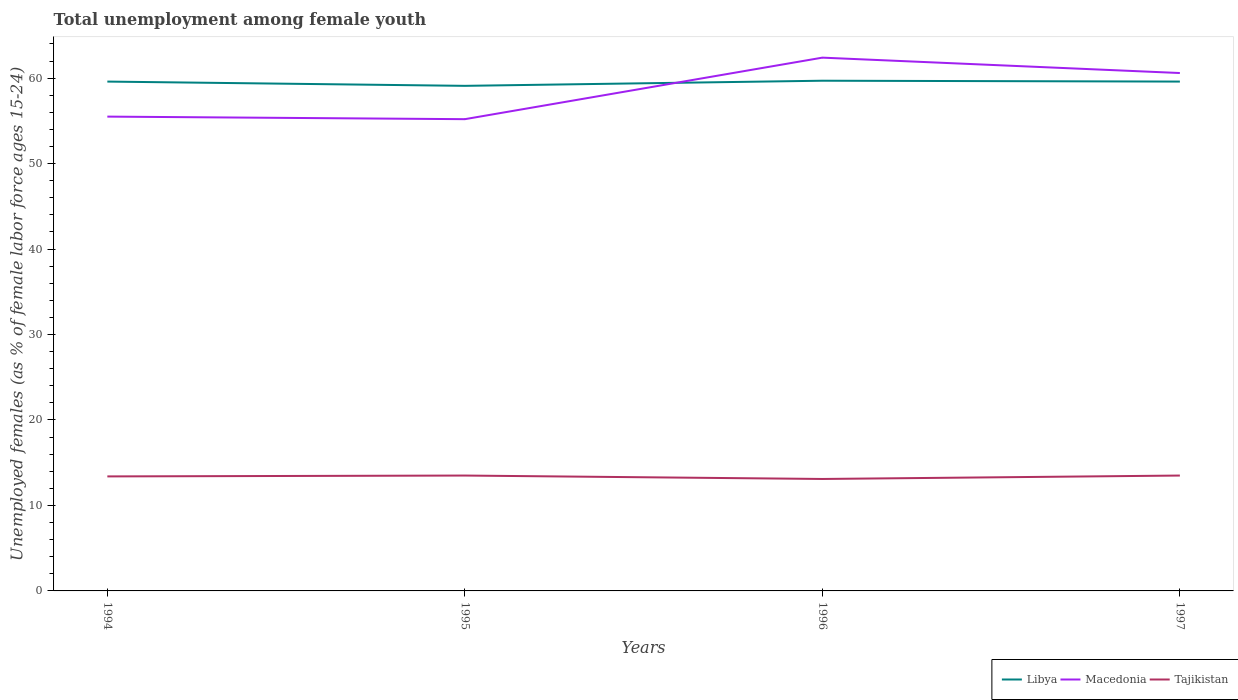Across all years, what is the maximum percentage of unemployed females in in Libya?
Your answer should be very brief. 59.1. What is the total percentage of unemployed females in in Macedonia in the graph?
Your answer should be compact. 1.8. What is the difference between the highest and the second highest percentage of unemployed females in in Macedonia?
Provide a short and direct response. 7.2. How many years are there in the graph?
Give a very brief answer. 4. What is the difference between two consecutive major ticks on the Y-axis?
Your answer should be compact. 10. Are the values on the major ticks of Y-axis written in scientific E-notation?
Make the answer very short. No. Does the graph contain any zero values?
Provide a short and direct response. No. Does the graph contain grids?
Give a very brief answer. No. Where does the legend appear in the graph?
Offer a very short reply. Bottom right. How many legend labels are there?
Give a very brief answer. 3. How are the legend labels stacked?
Offer a terse response. Horizontal. What is the title of the graph?
Give a very brief answer. Total unemployment among female youth. What is the label or title of the Y-axis?
Provide a short and direct response. Unemployed females (as % of female labor force ages 15-24). What is the Unemployed females (as % of female labor force ages 15-24) of Libya in 1994?
Make the answer very short. 59.6. What is the Unemployed females (as % of female labor force ages 15-24) of Macedonia in 1994?
Offer a very short reply. 55.5. What is the Unemployed females (as % of female labor force ages 15-24) of Tajikistan in 1994?
Give a very brief answer. 13.4. What is the Unemployed females (as % of female labor force ages 15-24) in Libya in 1995?
Offer a very short reply. 59.1. What is the Unemployed females (as % of female labor force ages 15-24) of Macedonia in 1995?
Provide a short and direct response. 55.2. What is the Unemployed females (as % of female labor force ages 15-24) in Libya in 1996?
Offer a very short reply. 59.7. What is the Unemployed females (as % of female labor force ages 15-24) of Macedonia in 1996?
Provide a succinct answer. 62.4. What is the Unemployed females (as % of female labor force ages 15-24) in Tajikistan in 1996?
Offer a very short reply. 13.1. What is the Unemployed females (as % of female labor force ages 15-24) of Libya in 1997?
Ensure brevity in your answer.  59.6. What is the Unemployed females (as % of female labor force ages 15-24) in Macedonia in 1997?
Make the answer very short. 60.6. What is the Unemployed females (as % of female labor force ages 15-24) in Tajikistan in 1997?
Ensure brevity in your answer.  13.5. Across all years, what is the maximum Unemployed females (as % of female labor force ages 15-24) in Libya?
Your answer should be very brief. 59.7. Across all years, what is the maximum Unemployed females (as % of female labor force ages 15-24) of Macedonia?
Your response must be concise. 62.4. Across all years, what is the minimum Unemployed females (as % of female labor force ages 15-24) in Libya?
Ensure brevity in your answer.  59.1. Across all years, what is the minimum Unemployed females (as % of female labor force ages 15-24) of Macedonia?
Give a very brief answer. 55.2. Across all years, what is the minimum Unemployed females (as % of female labor force ages 15-24) in Tajikistan?
Provide a short and direct response. 13.1. What is the total Unemployed females (as % of female labor force ages 15-24) of Libya in the graph?
Offer a terse response. 238. What is the total Unemployed females (as % of female labor force ages 15-24) of Macedonia in the graph?
Provide a succinct answer. 233.7. What is the total Unemployed females (as % of female labor force ages 15-24) of Tajikistan in the graph?
Give a very brief answer. 53.5. What is the difference between the Unemployed females (as % of female labor force ages 15-24) of Macedonia in 1994 and that in 1995?
Offer a terse response. 0.3. What is the difference between the Unemployed females (as % of female labor force ages 15-24) in Libya in 1994 and that in 1996?
Provide a succinct answer. -0.1. What is the difference between the Unemployed females (as % of female labor force ages 15-24) of Libya in 1994 and that in 1997?
Your answer should be compact. 0. What is the difference between the Unemployed females (as % of female labor force ages 15-24) of Libya in 1995 and that in 1997?
Give a very brief answer. -0.5. What is the difference between the Unemployed females (as % of female labor force ages 15-24) of Libya in 1996 and that in 1997?
Your answer should be very brief. 0.1. What is the difference between the Unemployed females (as % of female labor force ages 15-24) in Tajikistan in 1996 and that in 1997?
Keep it short and to the point. -0.4. What is the difference between the Unemployed females (as % of female labor force ages 15-24) of Libya in 1994 and the Unemployed females (as % of female labor force ages 15-24) of Tajikistan in 1995?
Offer a terse response. 46.1. What is the difference between the Unemployed females (as % of female labor force ages 15-24) in Macedonia in 1994 and the Unemployed females (as % of female labor force ages 15-24) in Tajikistan in 1995?
Offer a very short reply. 42. What is the difference between the Unemployed females (as % of female labor force ages 15-24) of Libya in 1994 and the Unemployed females (as % of female labor force ages 15-24) of Tajikistan in 1996?
Make the answer very short. 46.5. What is the difference between the Unemployed females (as % of female labor force ages 15-24) of Macedonia in 1994 and the Unemployed females (as % of female labor force ages 15-24) of Tajikistan in 1996?
Offer a terse response. 42.4. What is the difference between the Unemployed females (as % of female labor force ages 15-24) in Libya in 1994 and the Unemployed females (as % of female labor force ages 15-24) in Macedonia in 1997?
Your answer should be compact. -1. What is the difference between the Unemployed females (as % of female labor force ages 15-24) of Libya in 1994 and the Unemployed females (as % of female labor force ages 15-24) of Tajikistan in 1997?
Keep it short and to the point. 46.1. What is the difference between the Unemployed females (as % of female labor force ages 15-24) in Libya in 1995 and the Unemployed females (as % of female labor force ages 15-24) in Tajikistan in 1996?
Your answer should be compact. 46. What is the difference between the Unemployed females (as % of female labor force ages 15-24) in Macedonia in 1995 and the Unemployed females (as % of female labor force ages 15-24) in Tajikistan in 1996?
Ensure brevity in your answer.  42.1. What is the difference between the Unemployed females (as % of female labor force ages 15-24) of Libya in 1995 and the Unemployed females (as % of female labor force ages 15-24) of Macedonia in 1997?
Your response must be concise. -1.5. What is the difference between the Unemployed females (as % of female labor force ages 15-24) in Libya in 1995 and the Unemployed females (as % of female labor force ages 15-24) in Tajikistan in 1997?
Keep it short and to the point. 45.6. What is the difference between the Unemployed females (as % of female labor force ages 15-24) of Macedonia in 1995 and the Unemployed females (as % of female labor force ages 15-24) of Tajikistan in 1997?
Your answer should be very brief. 41.7. What is the difference between the Unemployed females (as % of female labor force ages 15-24) of Libya in 1996 and the Unemployed females (as % of female labor force ages 15-24) of Tajikistan in 1997?
Your answer should be compact. 46.2. What is the difference between the Unemployed females (as % of female labor force ages 15-24) in Macedonia in 1996 and the Unemployed females (as % of female labor force ages 15-24) in Tajikistan in 1997?
Provide a succinct answer. 48.9. What is the average Unemployed females (as % of female labor force ages 15-24) of Libya per year?
Your answer should be compact. 59.5. What is the average Unemployed females (as % of female labor force ages 15-24) in Macedonia per year?
Keep it short and to the point. 58.42. What is the average Unemployed females (as % of female labor force ages 15-24) of Tajikistan per year?
Offer a terse response. 13.38. In the year 1994, what is the difference between the Unemployed females (as % of female labor force ages 15-24) of Libya and Unemployed females (as % of female labor force ages 15-24) of Tajikistan?
Ensure brevity in your answer.  46.2. In the year 1994, what is the difference between the Unemployed females (as % of female labor force ages 15-24) of Macedonia and Unemployed females (as % of female labor force ages 15-24) of Tajikistan?
Your answer should be very brief. 42.1. In the year 1995, what is the difference between the Unemployed females (as % of female labor force ages 15-24) in Libya and Unemployed females (as % of female labor force ages 15-24) in Tajikistan?
Your answer should be very brief. 45.6. In the year 1995, what is the difference between the Unemployed females (as % of female labor force ages 15-24) of Macedonia and Unemployed females (as % of female labor force ages 15-24) of Tajikistan?
Your response must be concise. 41.7. In the year 1996, what is the difference between the Unemployed females (as % of female labor force ages 15-24) in Libya and Unemployed females (as % of female labor force ages 15-24) in Macedonia?
Your answer should be compact. -2.7. In the year 1996, what is the difference between the Unemployed females (as % of female labor force ages 15-24) in Libya and Unemployed females (as % of female labor force ages 15-24) in Tajikistan?
Give a very brief answer. 46.6. In the year 1996, what is the difference between the Unemployed females (as % of female labor force ages 15-24) of Macedonia and Unemployed females (as % of female labor force ages 15-24) of Tajikistan?
Provide a short and direct response. 49.3. In the year 1997, what is the difference between the Unemployed females (as % of female labor force ages 15-24) of Libya and Unemployed females (as % of female labor force ages 15-24) of Tajikistan?
Offer a very short reply. 46.1. In the year 1997, what is the difference between the Unemployed females (as % of female labor force ages 15-24) of Macedonia and Unemployed females (as % of female labor force ages 15-24) of Tajikistan?
Give a very brief answer. 47.1. What is the ratio of the Unemployed females (as % of female labor force ages 15-24) of Libya in 1994 to that in 1995?
Your response must be concise. 1.01. What is the ratio of the Unemployed females (as % of female labor force ages 15-24) in Macedonia in 1994 to that in 1995?
Provide a short and direct response. 1.01. What is the ratio of the Unemployed females (as % of female labor force ages 15-24) of Libya in 1994 to that in 1996?
Give a very brief answer. 1. What is the ratio of the Unemployed females (as % of female labor force ages 15-24) of Macedonia in 1994 to that in 1996?
Keep it short and to the point. 0.89. What is the ratio of the Unemployed females (as % of female labor force ages 15-24) of Tajikistan in 1994 to that in 1996?
Ensure brevity in your answer.  1.02. What is the ratio of the Unemployed females (as % of female labor force ages 15-24) in Libya in 1994 to that in 1997?
Your answer should be very brief. 1. What is the ratio of the Unemployed females (as % of female labor force ages 15-24) of Macedonia in 1994 to that in 1997?
Make the answer very short. 0.92. What is the ratio of the Unemployed females (as % of female labor force ages 15-24) of Libya in 1995 to that in 1996?
Provide a short and direct response. 0.99. What is the ratio of the Unemployed females (as % of female labor force ages 15-24) of Macedonia in 1995 to that in 1996?
Ensure brevity in your answer.  0.88. What is the ratio of the Unemployed females (as % of female labor force ages 15-24) of Tajikistan in 1995 to that in 1996?
Provide a succinct answer. 1.03. What is the ratio of the Unemployed females (as % of female labor force ages 15-24) in Libya in 1995 to that in 1997?
Your answer should be very brief. 0.99. What is the ratio of the Unemployed females (as % of female labor force ages 15-24) in Macedonia in 1995 to that in 1997?
Your response must be concise. 0.91. What is the ratio of the Unemployed females (as % of female labor force ages 15-24) in Tajikistan in 1995 to that in 1997?
Offer a terse response. 1. What is the ratio of the Unemployed females (as % of female labor force ages 15-24) in Macedonia in 1996 to that in 1997?
Provide a short and direct response. 1.03. What is the ratio of the Unemployed females (as % of female labor force ages 15-24) of Tajikistan in 1996 to that in 1997?
Make the answer very short. 0.97. What is the difference between the highest and the second highest Unemployed females (as % of female labor force ages 15-24) in Tajikistan?
Ensure brevity in your answer.  0. What is the difference between the highest and the lowest Unemployed females (as % of female labor force ages 15-24) in Libya?
Give a very brief answer. 0.6. What is the difference between the highest and the lowest Unemployed females (as % of female labor force ages 15-24) of Tajikistan?
Offer a terse response. 0.4. 